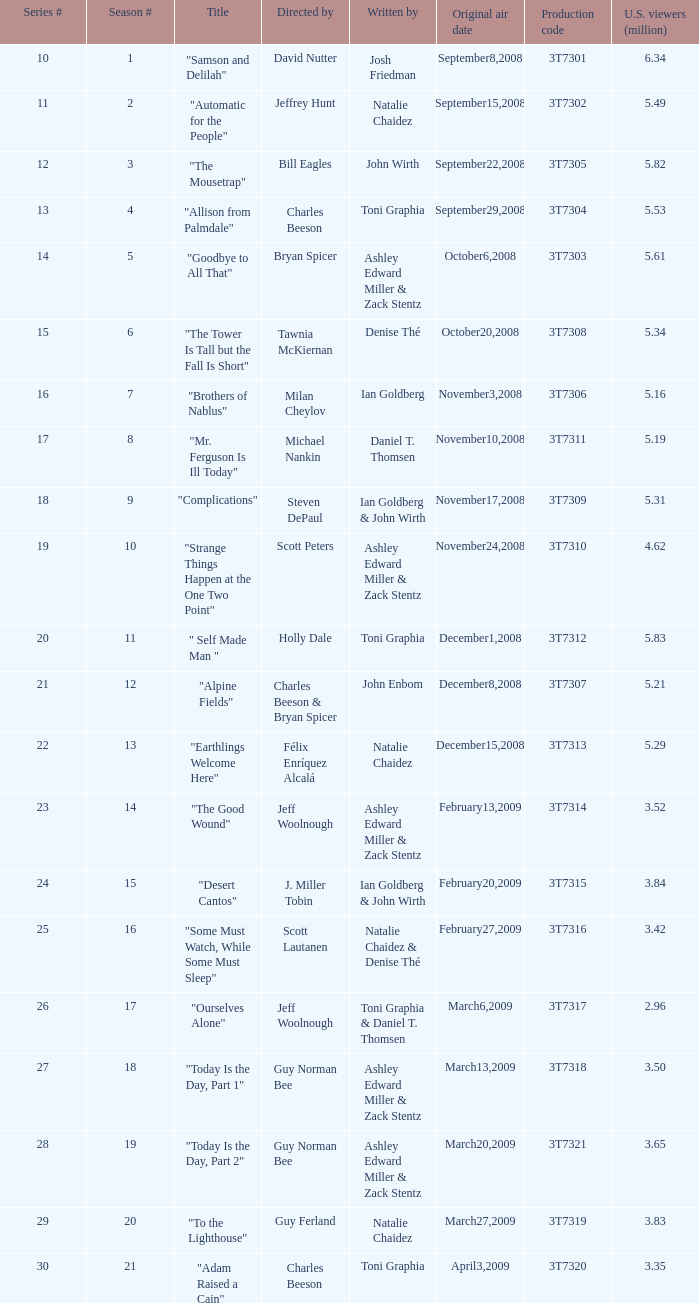What was the number of viewers for the episode directed by david nutter? 6.34. 